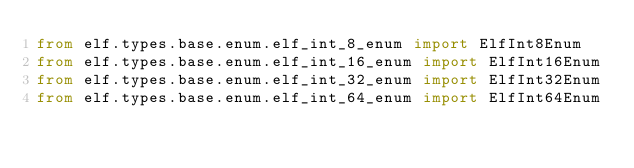Convert code to text. <code><loc_0><loc_0><loc_500><loc_500><_Python_>from elf.types.base.enum.elf_int_8_enum import ElfInt8Enum
from elf.types.base.enum.elf_int_16_enum import ElfInt16Enum
from elf.types.base.enum.elf_int_32_enum import ElfInt32Enum
from elf.types.base.enum.elf_int_64_enum import ElfInt64Enum
</code> 